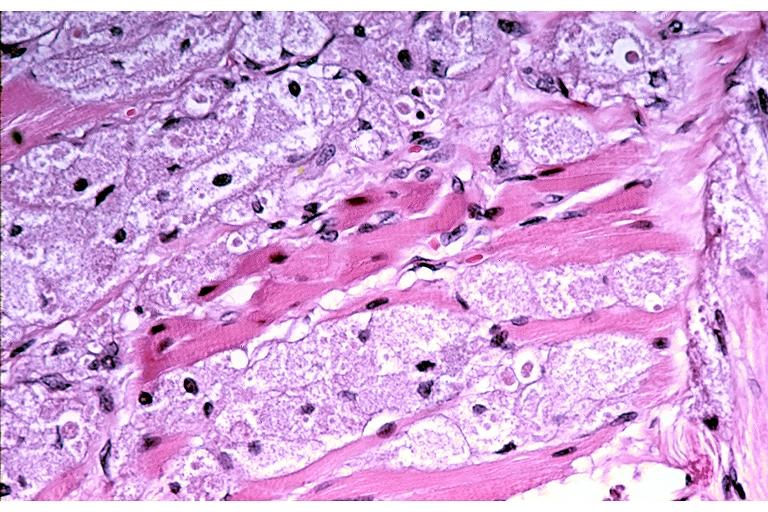s nodular tumor present?
Answer the question using a single word or phrase. No 